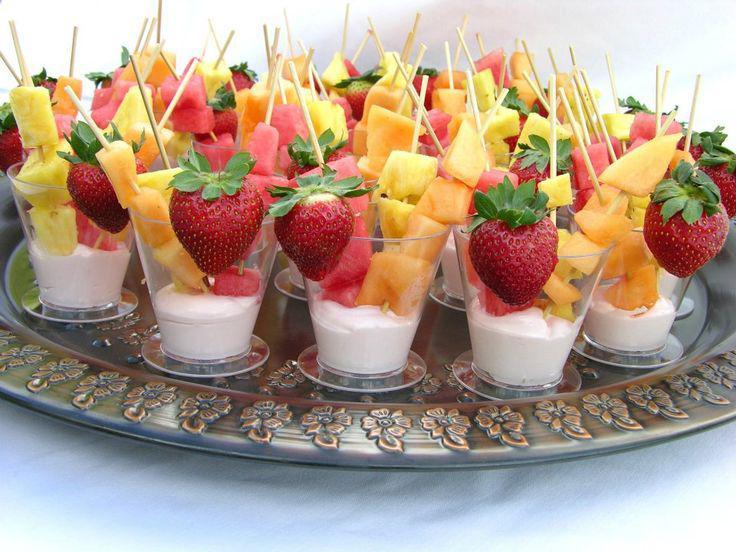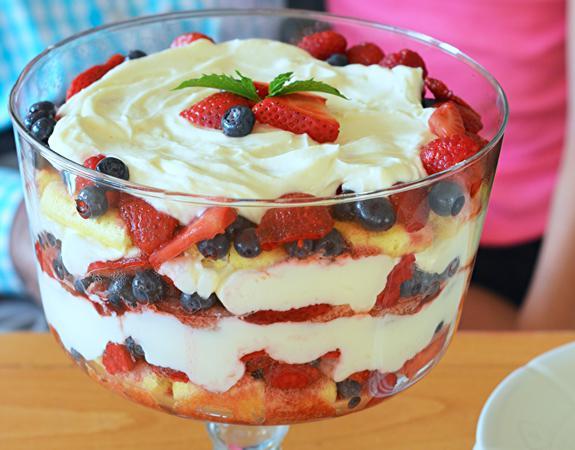The first image is the image on the left, the second image is the image on the right. Analyze the images presented: Is the assertion "The desserts in one of the images are dished out into single servings." valid? Answer yes or no. Yes. 